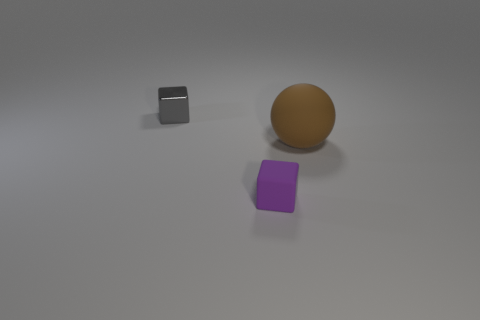Are there any purple rubber blocks to the right of the purple block?
Your response must be concise. No. There is a object on the right side of the purple cube; is it the same shape as the small thing that is in front of the large matte ball?
Your answer should be very brief. No. There is another small thing that is the same shape as the small purple thing; what is it made of?
Your answer should be very brief. Metal. How many blocks are big green metal things or purple objects?
Ensure brevity in your answer.  1. How many small purple objects are the same material as the big ball?
Provide a short and direct response. 1. Do the object behind the matte sphere and the thing that is right of the purple object have the same material?
Keep it short and to the point. No. There is a tiny object that is in front of the tiny thing behind the brown matte sphere; how many big brown objects are in front of it?
Your answer should be compact. 0. Do the tiny cube that is right of the small metal block and the block that is behind the large brown rubber sphere have the same color?
Your answer should be very brief. No. Is there any other thing of the same color as the small rubber thing?
Offer a very short reply. No. There is a tiny thing in front of the small cube that is behind the sphere; what is its color?
Ensure brevity in your answer.  Purple. 